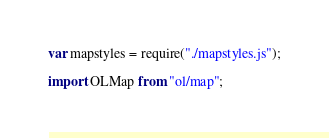Convert code to text. <code><loc_0><loc_0><loc_500><loc_500><_JavaScript_>var mapstyles = require("./mapstyles.js");

import OLMap from "ol/map";</code> 